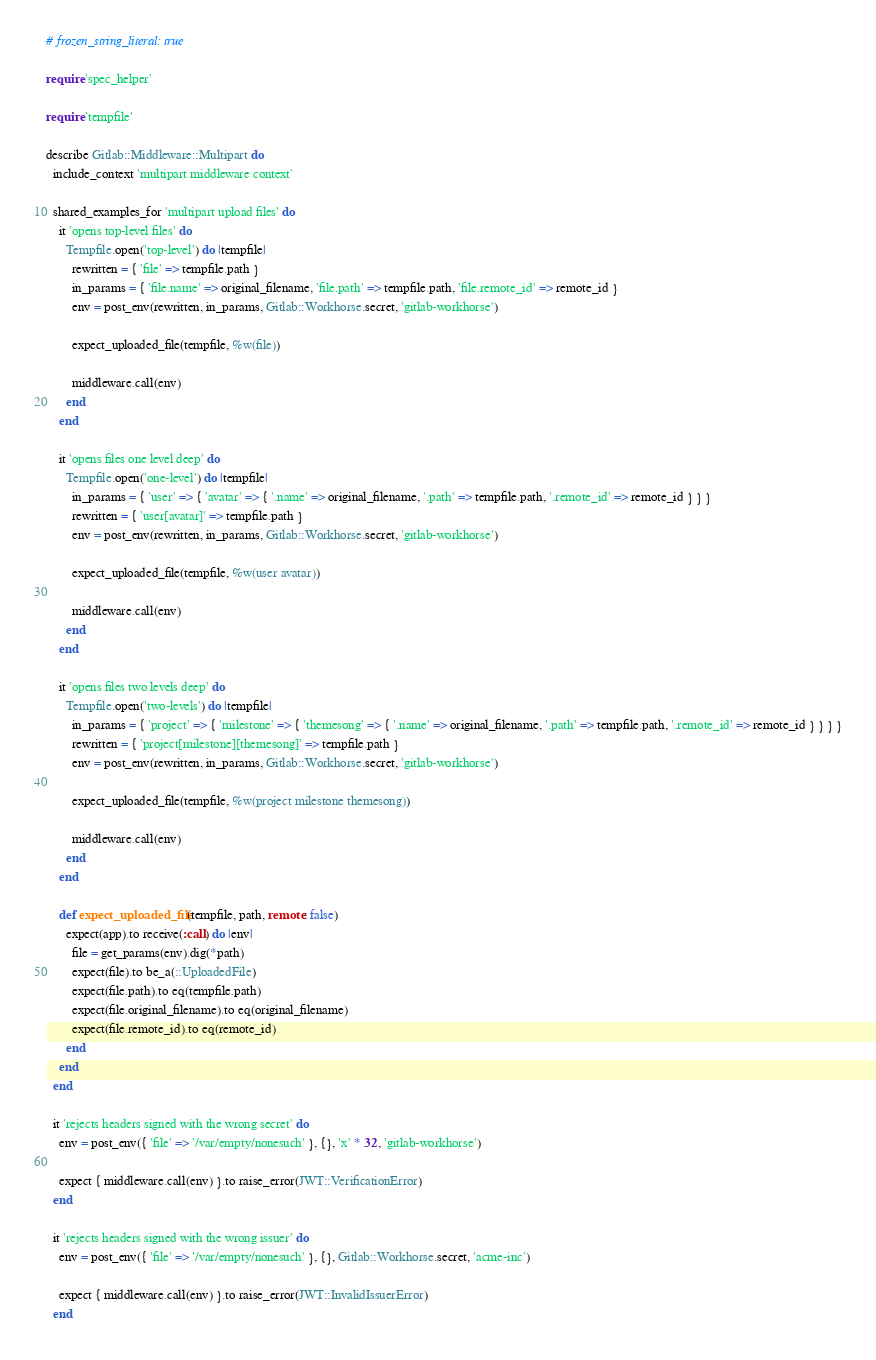Convert code to text. <code><loc_0><loc_0><loc_500><loc_500><_Ruby_># frozen_string_literal: true

require 'spec_helper'

require 'tempfile'

describe Gitlab::Middleware::Multipart do
  include_context 'multipart middleware context'

  shared_examples_for 'multipart upload files' do
    it 'opens top-level files' do
      Tempfile.open('top-level') do |tempfile|
        rewritten = { 'file' => tempfile.path }
        in_params = { 'file.name' => original_filename, 'file.path' => tempfile.path, 'file.remote_id' => remote_id }
        env = post_env(rewritten, in_params, Gitlab::Workhorse.secret, 'gitlab-workhorse')

        expect_uploaded_file(tempfile, %w(file))

        middleware.call(env)
      end
    end

    it 'opens files one level deep' do
      Tempfile.open('one-level') do |tempfile|
        in_params = { 'user' => { 'avatar' => { '.name' => original_filename, '.path' => tempfile.path, '.remote_id' => remote_id } } }
        rewritten = { 'user[avatar]' => tempfile.path }
        env = post_env(rewritten, in_params, Gitlab::Workhorse.secret, 'gitlab-workhorse')

        expect_uploaded_file(tempfile, %w(user avatar))

        middleware.call(env)
      end
    end

    it 'opens files two levels deep' do
      Tempfile.open('two-levels') do |tempfile|
        in_params = { 'project' => { 'milestone' => { 'themesong' => { '.name' => original_filename, '.path' => tempfile.path, '.remote_id' => remote_id } } } }
        rewritten = { 'project[milestone][themesong]' => tempfile.path }
        env = post_env(rewritten, in_params, Gitlab::Workhorse.secret, 'gitlab-workhorse')

        expect_uploaded_file(tempfile, %w(project milestone themesong))

        middleware.call(env)
      end
    end

    def expect_uploaded_file(tempfile, path, remote: false)
      expect(app).to receive(:call) do |env|
        file = get_params(env).dig(*path)
        expect(file).to be_a(::UploadedFile)
        expect(file.path).to eq(tempfile.path)
        expect(file.original_filename).to eq(original_filename)
        expect(file.remote_id).to eq(remote_id)
      end
    end
  end

  it 'rejects headers signed with the wrong secret' do
    env = post_env({ 'file' => '/var/empty/nonesuch' }, {}, 'x' * 32, 'gitlab-workhorse')

    expect { middleware.call(env) }.to raise_error(JWT::VerificationError)
  end

  it 'rejects headers signed with the wrong issuer' do
    env = post_env({ 'file' => '/var/empty/nonesuch' }, {}, Gitlab::Workhorse.secret, 'acme-inc')

    expect { middleware.call(env) }.to raise_error(JWT::InvalidIssuerError)
  end
</code> 